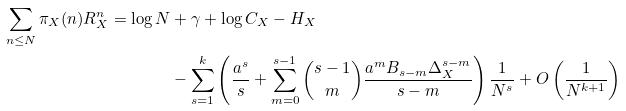Convert formula to latex. <formula><loc_0><loc_0><loc_500><loc_500>\sum _ { n \leq N } \pi _ { X } ( n ) R _ { X } ^ { n } = \log N & + \gamma + \log C _ { X } - H _ { X } \\ & - \sum _ { s = 1 } ^ { k } \left ( \frac { a ^ { s } } { s } + \sum _ { m = 0 } ^ { s - 1 } \binom { s - 1 } { m } \frac { a ^ { m } B _ { s - m } \Delta _ { X } ^ { s - m } } { s - m } \right ) \frac { 1 } { N ^ { s } } + O \left ( \frac { 1 } { N ^ { k + 1 } } \right )</formula> 